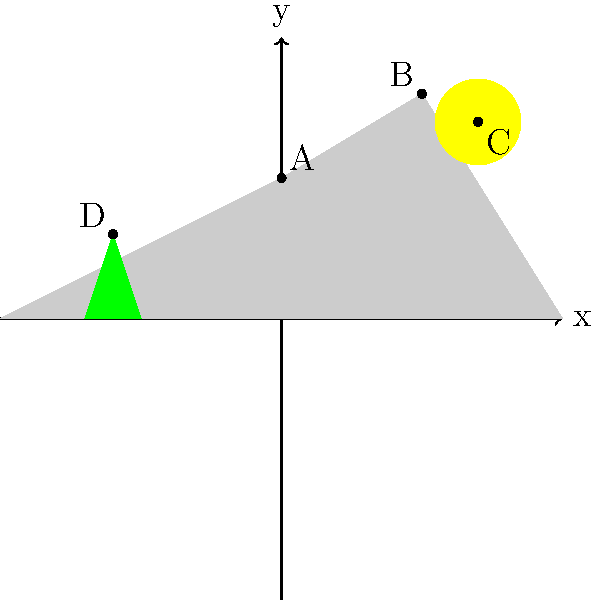In your stylized movie poster landscape inspired by a classic Western film, you've incorporated key elements at specific coordinates. The mountain peak is at point A(0, 5), the highest point is at B(5, 8), the sun's center is at C(7, 7), and the top of a lone tree is at D(-6, 3). What is the distance between the mountain peak (A) and the highest point (B)? To find the distance between two points in a coordinate plane, we can use the distance formula:

$d = \sqrt{(x_2 - x_1)^2 + (y_2 - y_1)^2}$

Where $(x_1, y_1)$ are the coordinates of the first point and $(x_2, y_2)$ are the coordinates of the second point.

Given:
Point A (mountain peak): $(0, 5)$
Point B (highest point): $(5, 8)$

Let's plug these values into the formula:

$d = \sqrt{(5 - 0)^2 + (8 - 5)^2}$

Simplify:
$d = \sqrt{5^2 + 3^2}$

$d = \sqrt{25 + 9}$

$d = \sqrt{34}$

Therefore, the distance between points A and B is $\sqrt{34}$ units.
Answer: $\sqrt{34}$ units 